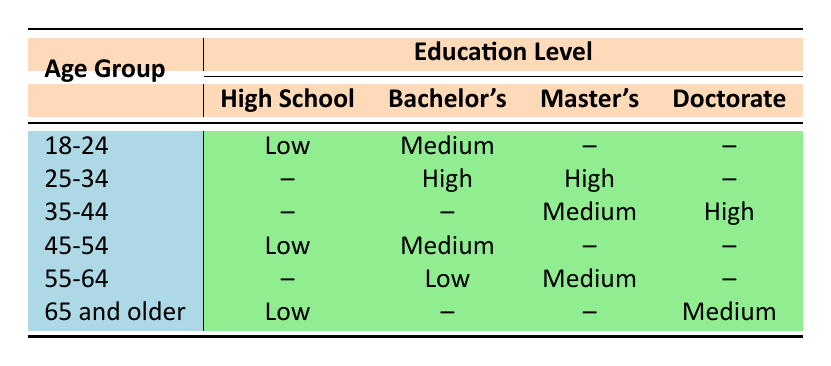What is the awareness level of 18-24 year-olds with a Bachelor's Degree? According to the table, 18-24 year-olds with a Bachelor's Degree have an Awareness Level of "Medium".
Answer: Medium Which age group has the highest awareness level based on the data? The age group 25-34 has the highest awareness level with both Bachelor's and Master's Degrees marked as "High".
Answer: 25-34 Is there any age group that shows a Low awareness level for Doctorate holders? The table indicates that there are no instances of a Doctorate holder being classified with a Low awareness level. Therefore, the statement is true.
Answer: No What percentage of individuals aged 45-54 have a medium awareness level? In the 45-54 age group, there are two individuals: one with High School who has Low awareness, and one with a Bachelor's Degree who has Medium awareness. So there is one person out of two with Medium awareness, which is (1/2) × 100 = 50%.
Answer: 50% Among individuals aged 55-64, which education level shows a Medium awareness level? The table shows that individuals aged 55-64 with a Master's Degree have a Medium awareness level.
Answer: Master's Degree 